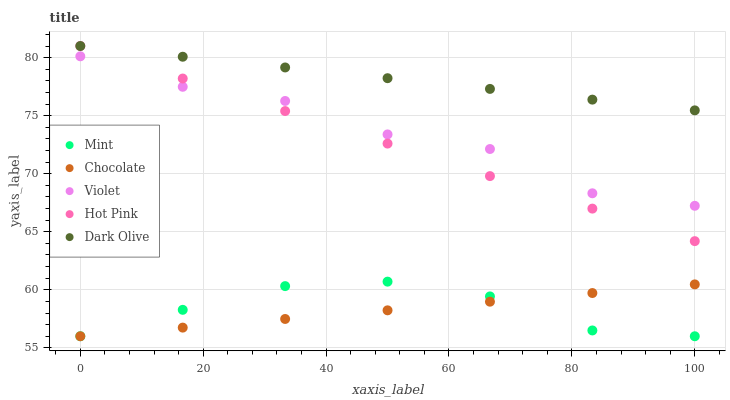Does Chocolate have the minimum area under the curve?
Answer yes or no. Yes. Does Dark Olive have the maximum area under the curve?
Answer yes or no. Yes. Does Hot Pink have the minimum area under the curve?
Answer yes or no. No. Does Hot Pink have the maximum area under the curve?
Answer yes or no. No. Is Chocolate the smoothest?
Answer yes or no. Yes. Is Violet the roughest?
Answer yes or no. Yes. Is Hot Pink the smoothest?
Answer yes or no. No. Is Hot Pink the roughest?
Answer yes or no. No. Does Mint have the lowest value?
Answer yes or no. Yes. Does Hot Pink have the lowest value?
Answer yes or no. No. Does Hot Pink have the highest value?
Answer yes or no. Yes. Does Violet have the highest value?
Answer yes or no. No. Is Mint less than Hot Pink?
Answer yes or no. Yes. Is Hot Pink greater than Chocolate?
Answer yes or no. Yes. Does Mint intersect Chocolate?
Answer yes or no. Yes. Is Mint less than Chocolate?
Answer yes or no. No. Is Mint greater than Chocolate?
Answer yes or no. No. Does Mint intersect Hot Pink?
Answer yes or no. No. 